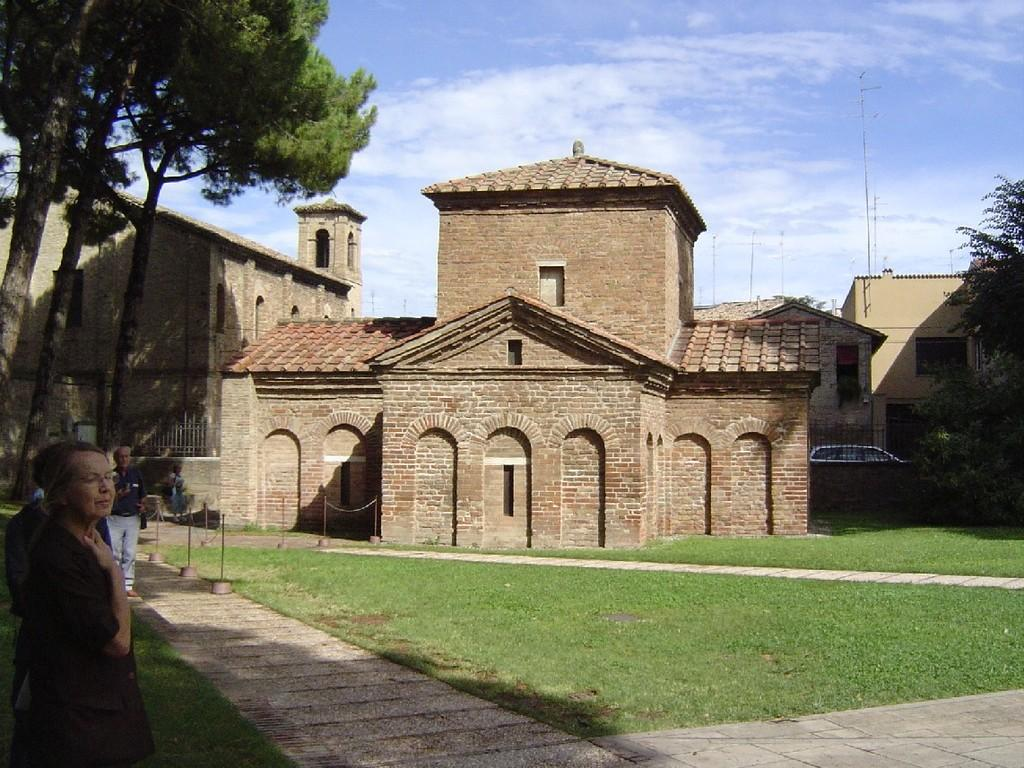What are the people in the image doing? The people in the image are walking. On what surfaces are the people walking? The people are walking on grass and pavement. What structures can be seen beside the grass? There are buildings beside the grass. What type of vehicles can be seen in the image? Cars are visible in the image. What type of vegetation is present in the image? Trees are present in the image. What part of the car is rolling down the street in the image? There is no car part rolling down the street in the image; the cars are stationary. What type of oil can be seen dripping from the trees in the image? There is no oil present in the image; only trees are visible. 